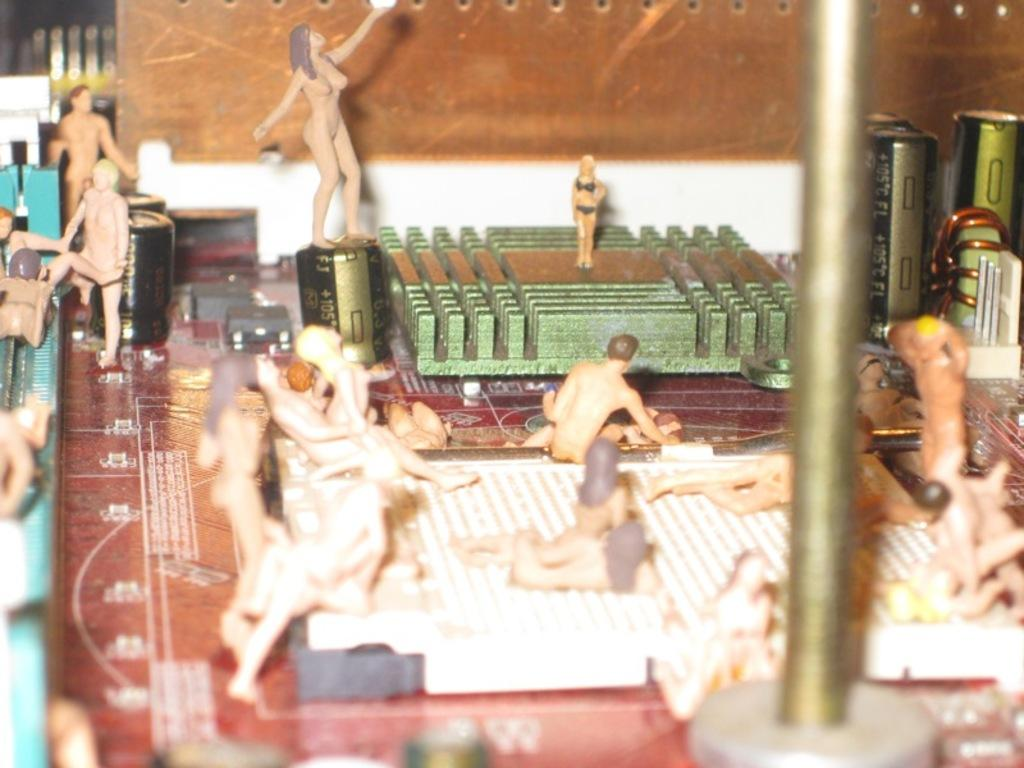What type of objects can be seen in the image? There are toys in the image. Are there any specific items related to the toys? Yes, there are batteries in the image. What material is the metal rod made of? The metal rod in the image is made of metal. Can you describe any other objects present in the image? There are other objects in the image, but their specific details are not mentioned in the provided facts. What type of map can be seen in the image? There is no map present in the image. What color is the skirt in the image? There is no skirt present in the image. 